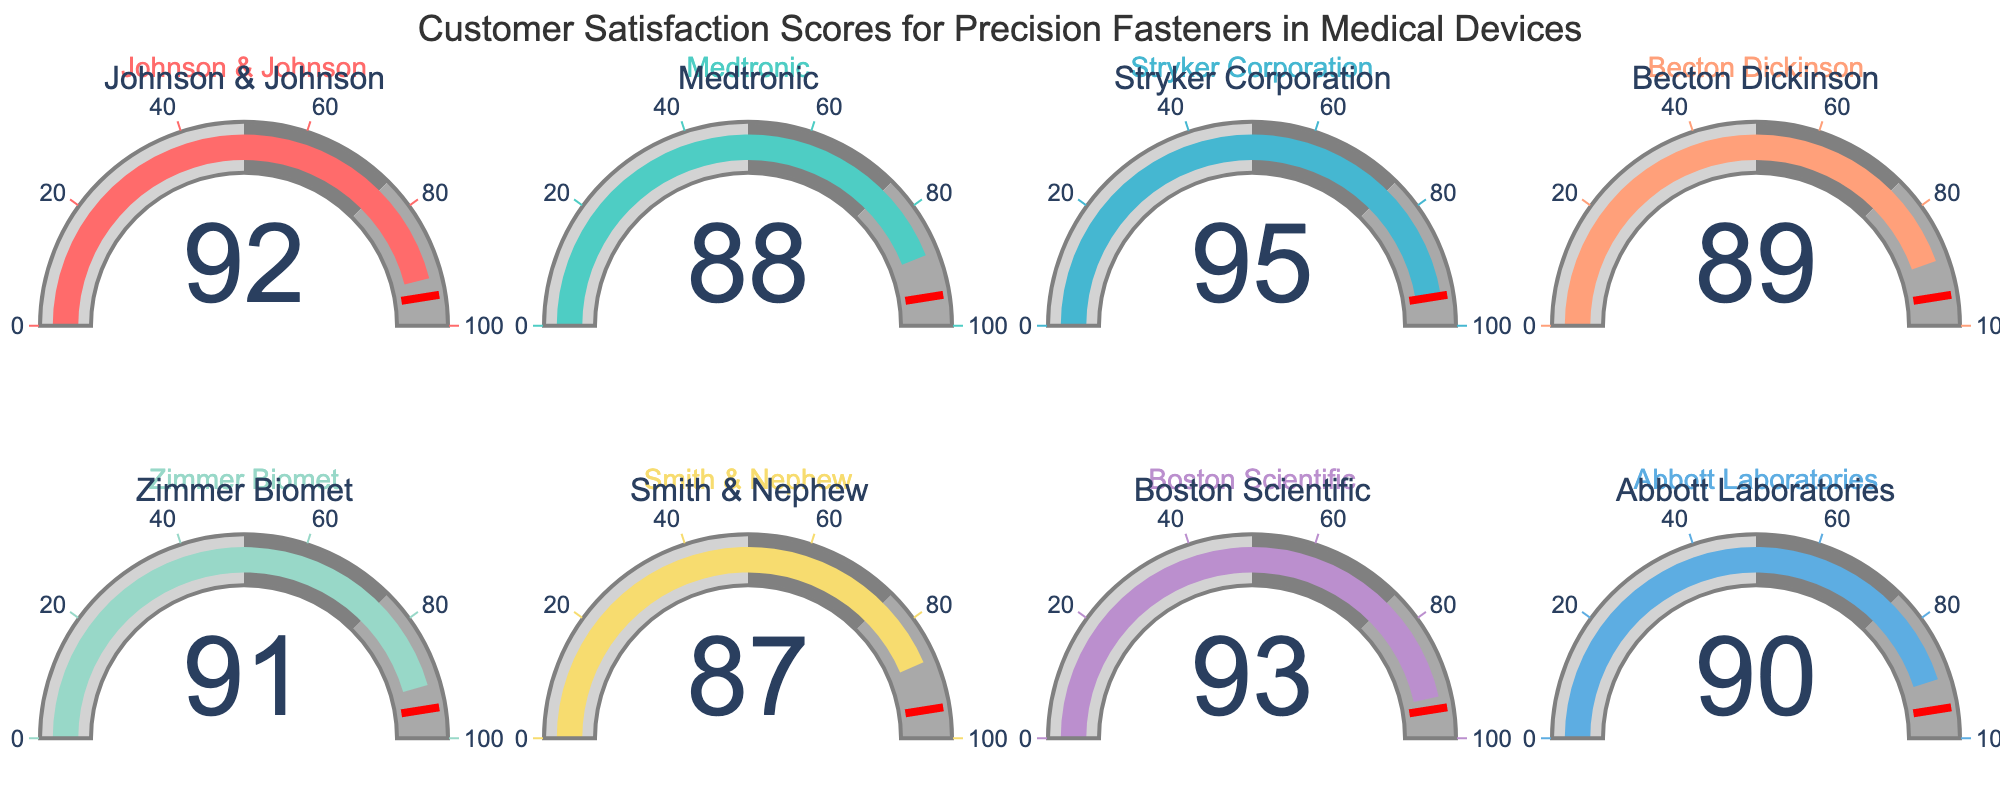What is the highest customer satisfaction score displayed on the gauges? The highest customer satisfaction score can be identified by looking for the gauge that shows the largest number. In this case, the highest score shown is 95 by Stryker Corporation.
Answer: 95 Which company has the lowest customer satisfaction score? To determine the company with the lowest score, we look for the smallest number shown on any of the gauges. Smith & Nephew has the lowest score, which is 87.
Answer: Smith & Nephew What is the average customer satisfaction score of the companies? To calculate the average score, sum all the scores and divide by the total number of companies. The scores are 92, 88, 95, 89, 91, 87, 93, and 90. The sum is 725. There are 8 companies, so the average score is 725/8.
Answer: 90.625 How many companies scored above 90? To find the number of companies scoring above 90, count the gauges displaying values greater than 90. They are Johnson & Johnson (92), Stryker Corporation (95), Boston Scientific (93), and Zimmer Biomet (91).
Answer: 4 Do any companies have the same satisfaction score? By comparing the scores on all gauges, we can see if any two companies have identical scores. In this case, no two companies have the same score; each one is unique.
Answer: No What is the total satisfaction score of all companies combined? To find the total satisfaction score, sum the scores of all the companies: 92, 88, 95, 89, 91, 87, 93, and 90, resulting in a total of 725.
Answer: 725 Which company has a satisfaction score closest to the average score? First, calculate the average score (90.625). Then, determine the difference between each company's score and the average. The company with the smallest difference is Abbott Laboratories (score of 90, difference of 0.625).
Answer: Abbott Laboratories What is the median customer satisfaction score among the companies? To find the median score, list all scores in ascending order: 87, 88, 89, 90, 91, 92, 93, 95. With 8 scores, the median is the average of the 4th and 5th scores, (90+91)/2.
Answer: 90.5 What is the range of customer satisfaction scores among the companies? The range is calculated by subtracting the smallest score (87 from Smith & Nephew) from the largest score (95 from Stryker Corporation).
Answer: 8 